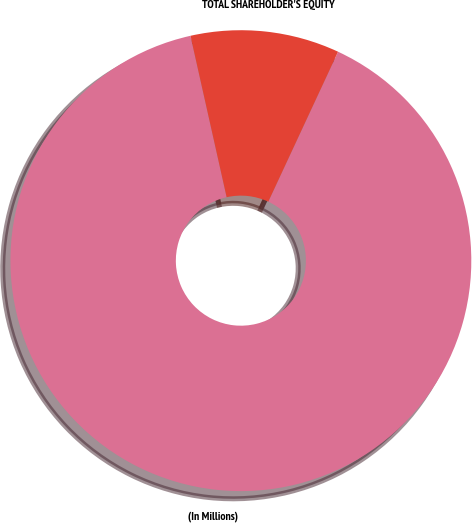Convert chart. <chart><loc_0><loc_0><loc_500><loc_500><pie_chart><fcel>(In Millions)<fcel>TOTAL SHAREHOLDER'S EQUITY<nl><fcel>89.56%<fcel>10.44%<nl></chart> 